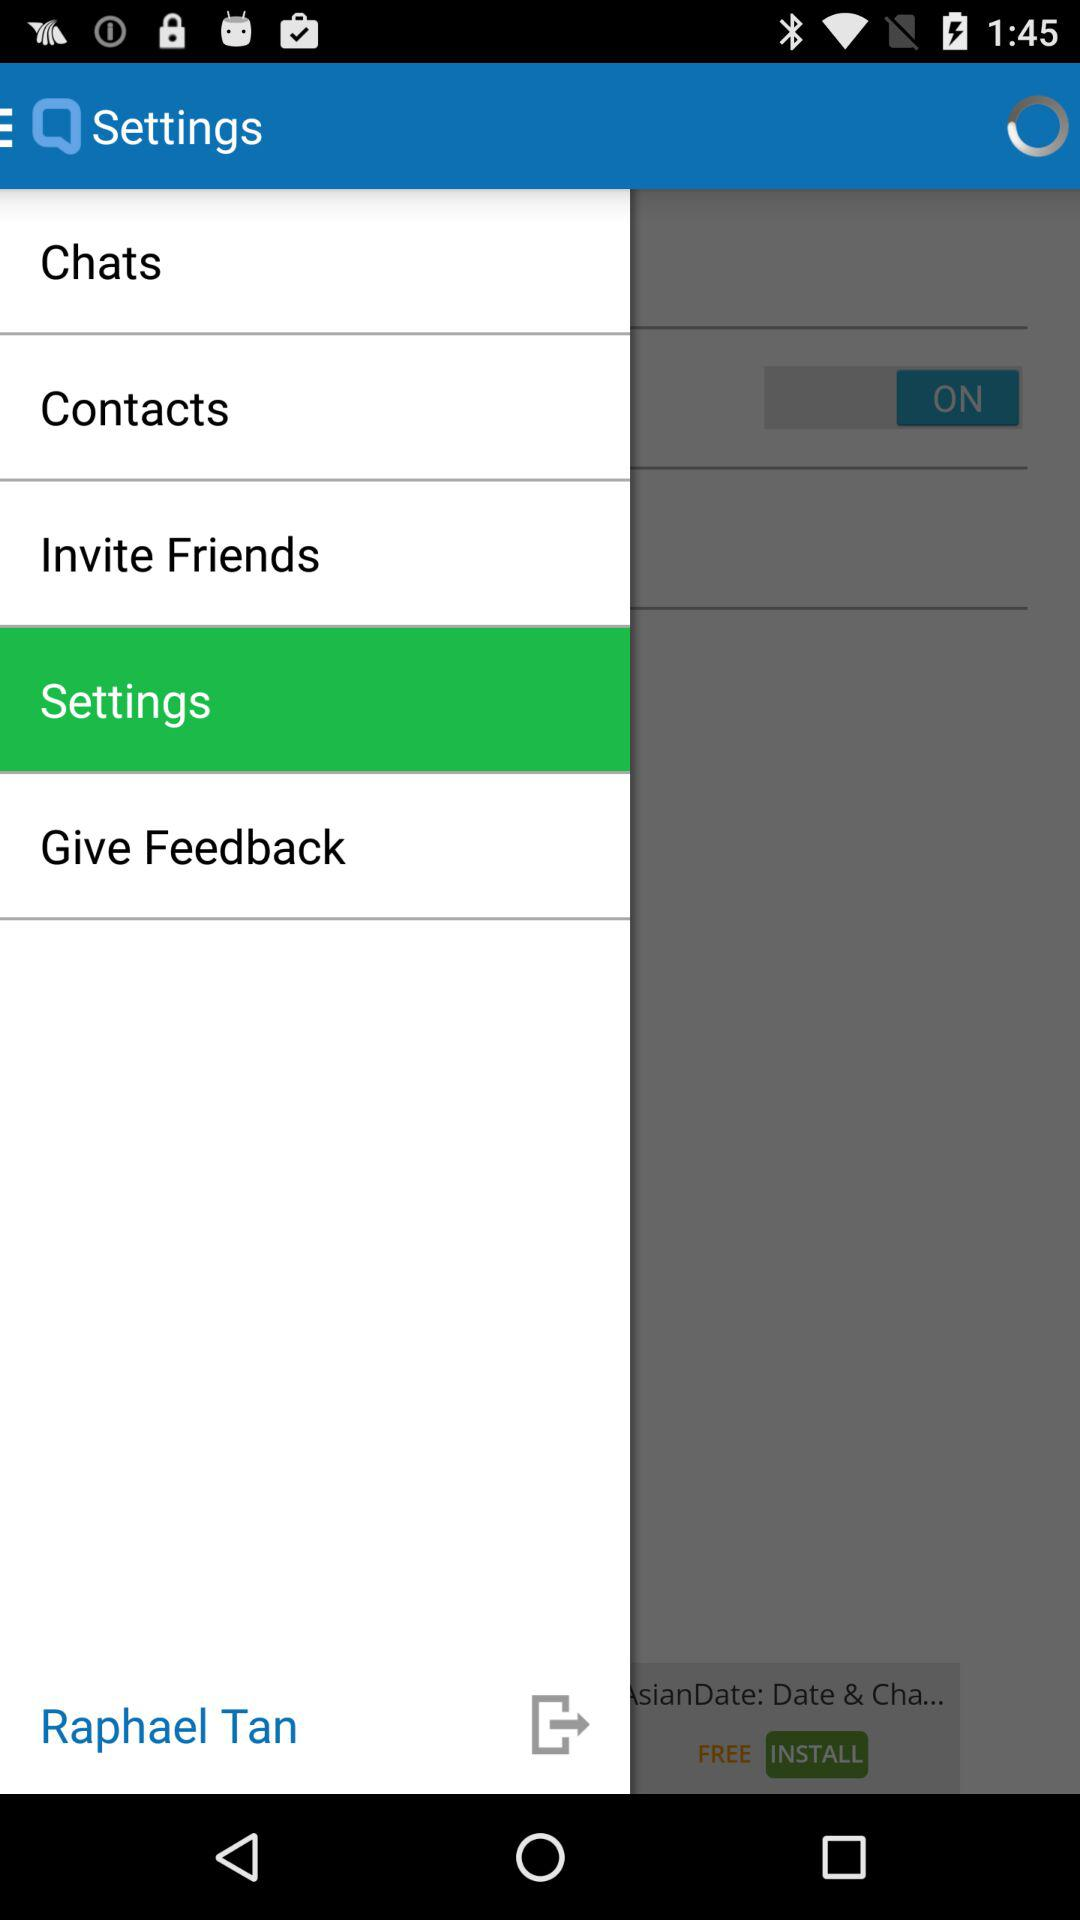Whose name is shown? The name shown is Raphael Tan. 